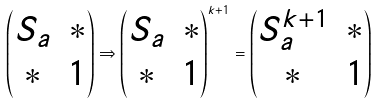<formula> <loc_0><loc_0><loc_500><loc_500>\left ( \begin{matrix} S _ { a } & * \\ * & 1 \end{matrix} \right ) \Rightarrow \left ( \begin{matrix} S _ { a } & * \\ * & 1 \end{matrix} \right ) ^ { k + 1 } = \left ( \begin{matrix} S _ { a } ^ { k + 1 } & * \\ * & 1 \end{matrix} \right )</formula> 